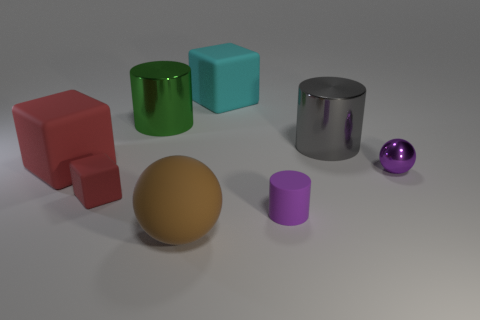Are there more gray metallic objects in front of the large brown matte ball than big red rubber objects?
Ensure brevity in your answer.  No. There is a big metal cylinder that is on the right side of the small cylinder; what is its color?
Offer a terse response. Gray. The metal sphere that is the same color as the tiny cylinder is what size?
Give a very brief answer. Small. How many shiny things are either large cyan blocks or large green cylinders?
Offer a very short reply. 1. Is there a matte thing that is to the right of the big rubber cube that is behind the large shiny object that is left of the gray thing?
Keep it short and to the point. Yes. What number of metal balls are on the left side of the large sphere?
Your answer should be very brief. 0. What material is the thing that is the same color as the tiny ball?
Provide a short and direct response. Rubber. What number of tiny objects are purple objects or red cubes?
Provide a short and direct response. 3. The large metal thing on the right side of the green cylinder has what shape?
Provide a short and direct response. Cylinder. Is there a big ball that has the same color as the small cube?
Ensure brevity in your answer.  No. 